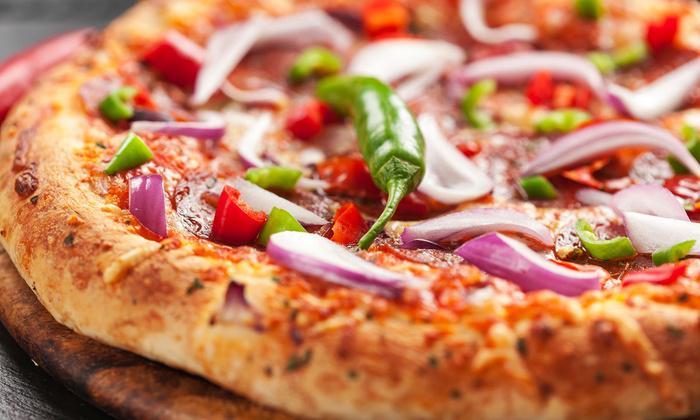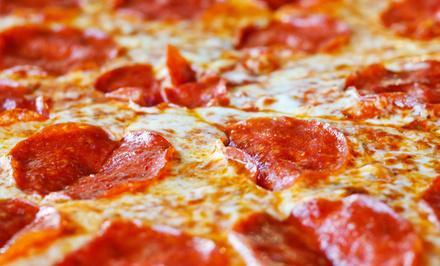The first image is the image on the left, the second image is the image on the right. Analyze the images presented: Is the assertion "One of the pizzas has onion on it." valid? Answer yes or no. Yes. The first image is the image on the left, the second image is the image on the right. Given the left and right images, does the statement "One image features a single round pizza that is not cut into slices, and the other image features one pepperoni pizza cut into wedge-shaped slices." hold true? Answer yes or no. Yes. 